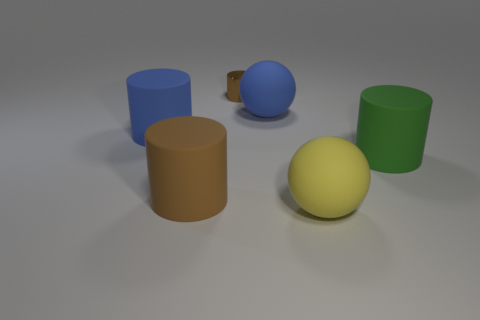Are there fewer large purple rubber things than small shiny objects?
Your answer should be compact. Yes. Are there any green matte cylinders to the left of the green thing?
Keep it short and to the point. No. Is the material of the green thing the same as the tiny brown thing?
Offer a very short reply. No. What color is the small shiny thing that is the same shape as the brown matte thing?
Ensure brevity in your answer.  Brown. There is a cylinder that is to the right of the big blue rubber ball; is its color the same as the small metal thing?
Make the answer very short. No. What shape is the large matte object that is the same color as the shiny cylinder?
Your answer should be very brief. Cylinder. What number of tiny things are made of the same material as the big green thing?
Your response must be concise. 0. There is a blue matte cylinder; what number of big matte cylinders are right of it?
Ensure brevity in your answer.  2. The blue cylinder has what size?
Offer a terse response. Large. There is another sphere that is the same size as the blue rubber ball; what is its color?
Keep it short and to the point. Yellow. 